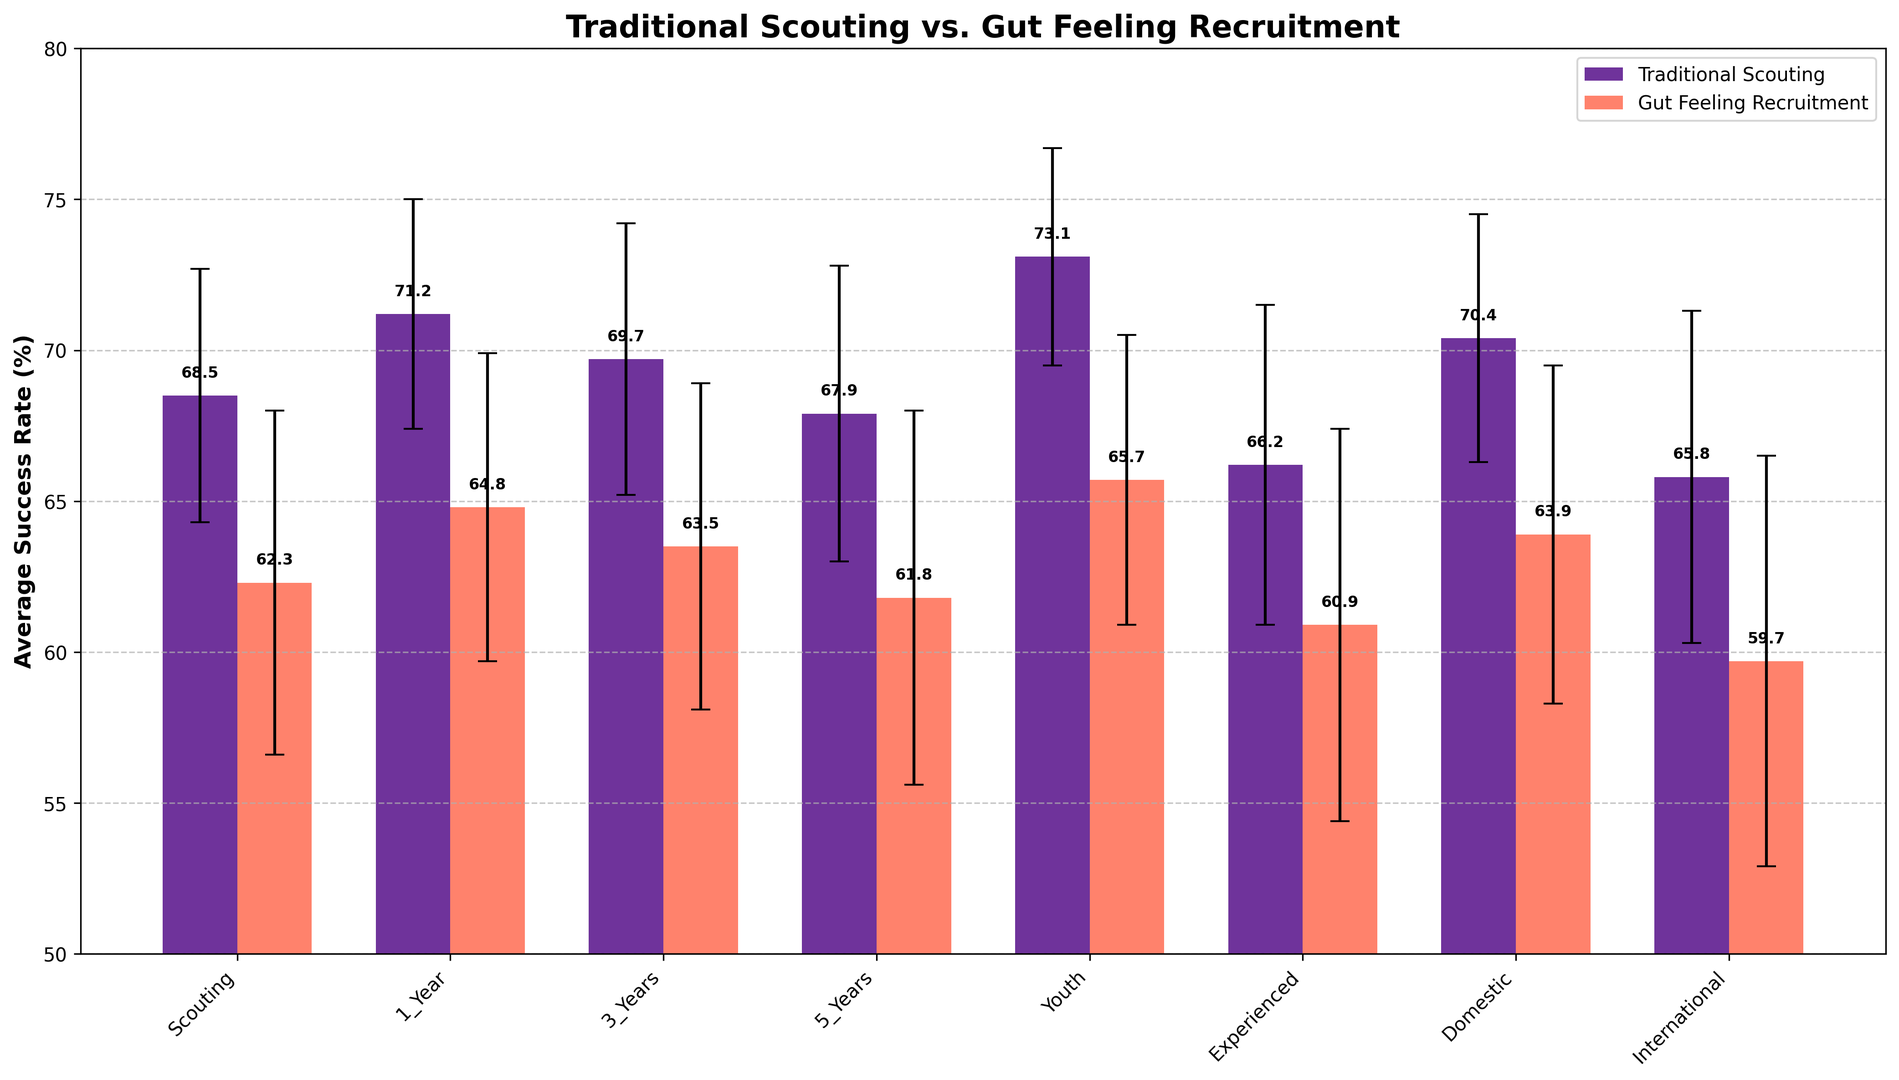What's the difference in average success rate between traditional scouting and gut-feeling recruitment for 1-year player development? First, locate the average success rates for "Traditional_1_Year" (71.2) and "Gut_Feeling_1_Year" (64.8). Subtract the gut-feeling value from the traditional value: 71.2 - 64.8.
Answer: 6.4 Which method has a higher average success rate for recruiting youth players? Locate the bars labeled "Traditional_Youth" and "Gut_Feeling_Youth". Compare their heights to find that "Traditional_Youth" (73.1) is higher than "Gut_Feeling_Youth" (65.7).
Answer: Traditional scouting What is the average success rate for traditional scouting players with 3-years of development and experienced players combined? Locate "Traditional_3_Years" (69.7) and "Traditional_Experienced" (66.2). Add their values and then divide by 2: (69.7 + 66.2) / 2.
Answer: 67.95 How do the error margins compare for gut-feeling recruitment between domestic and international players? Locate the error margins for "Gut_Feeling_Domestic" (5.6) and "Gut_Feeling_International" (6.8). Compare them to see that the international error margin is larger.
Answer: International has a larger error margin Which category shows the smallest difference in average success rate between traditional scouting and gut-feeling recruitment? Calculate the differences for each category: 
1-Year (6.4), 
3-Years (6.2), 
5-Years (6.1), 
Youth (7.4), 
Experienced (5.3), 
Domestic (6.5), 
International (6.1). 
The smallest difference is for "Experienced" players, 5.3.
Answer: Experienced players What is the overall trend in success rates for traditional scouting compared to gut-feeling recruitment across all categories? Observe the trend by comparing bars: Traditional scouting's success rates are consistently higher than gut-feeling recruitment in each category.
Answer: Traditional scouting is consistently higher How much higher is the highest success rate in traditional scouting compared to the highest in gut-feeling recruitment? Identify the highest success rates: "Traditional_Youth" (73.1) and "Gut_Feeling_Youth" (65.7). Subtract the gut-feeling rate from the traditional rate: 73.1 - 65.7.
Answer: 7.4 What is the relative error margin size for gut-feeling experienced players compared to traditional experienced players? Find the error margins for "Gut_Feeling_Experienced" (6.5) and "Traditional_Experienced" (5.3). Their relative size: 6.5 / 5.3 ≈ 1.23 (gut-feeling margin is about 1.23 times larger).
Answer: 1.23 times larger Which method demonstrates a higher consistency in success rates across all categories, and why? Observe the error bars: Traditional scouting generally has smaller error margins than gut-feeling recruitment, indicating higher consistency.
Answer: Traditional scouting shows higher consistency 